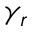<formula> <loc_0><loc_0><loc_500><loc_500>\gamma _ { r }</formula> 